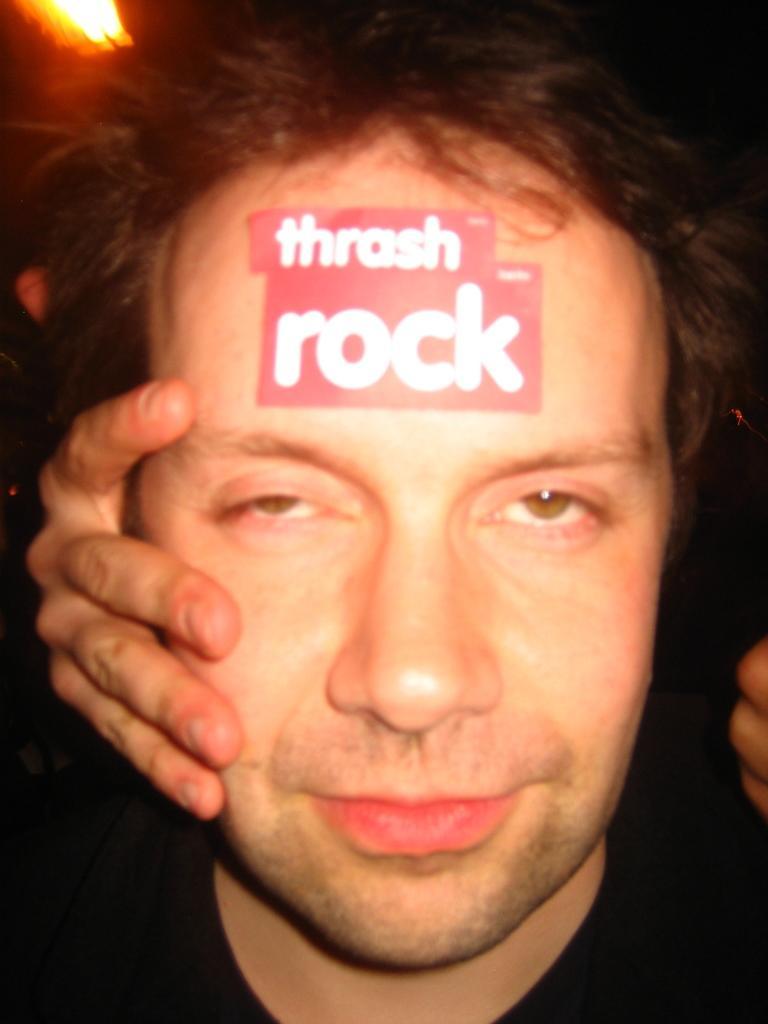How would you summarize this image in a sentence or two? In the image there is a man in the front with a sticker over his hand and a person holding his head and above there is light on the left side. 